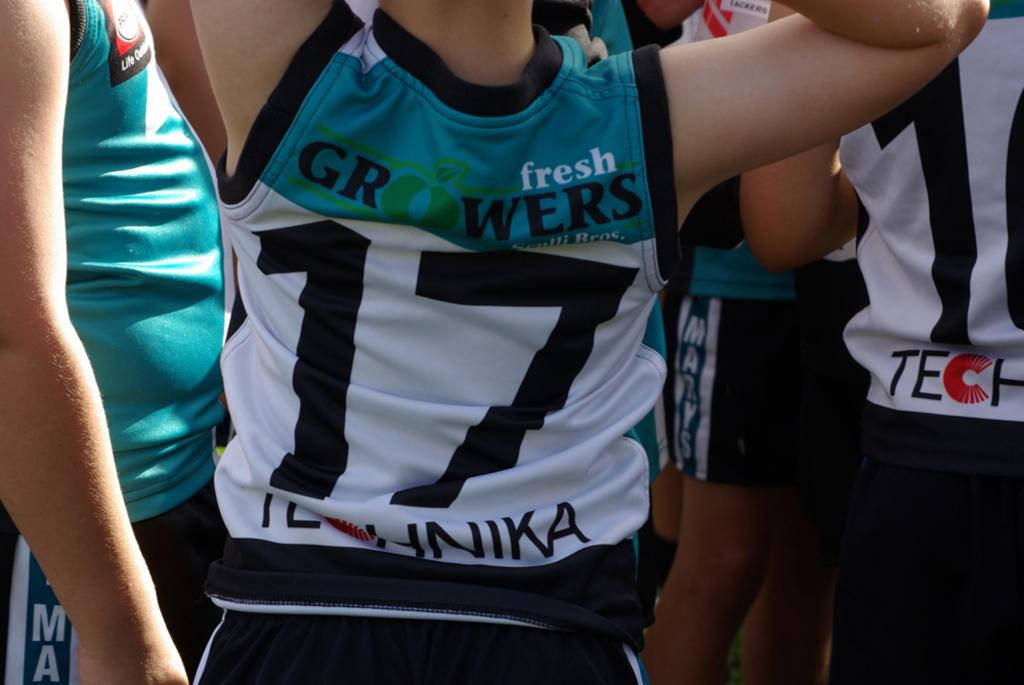<image>
Relay a brief, clear account of the picture shown. A person is wearing a fresh growers jersey with the number 17 on it. 